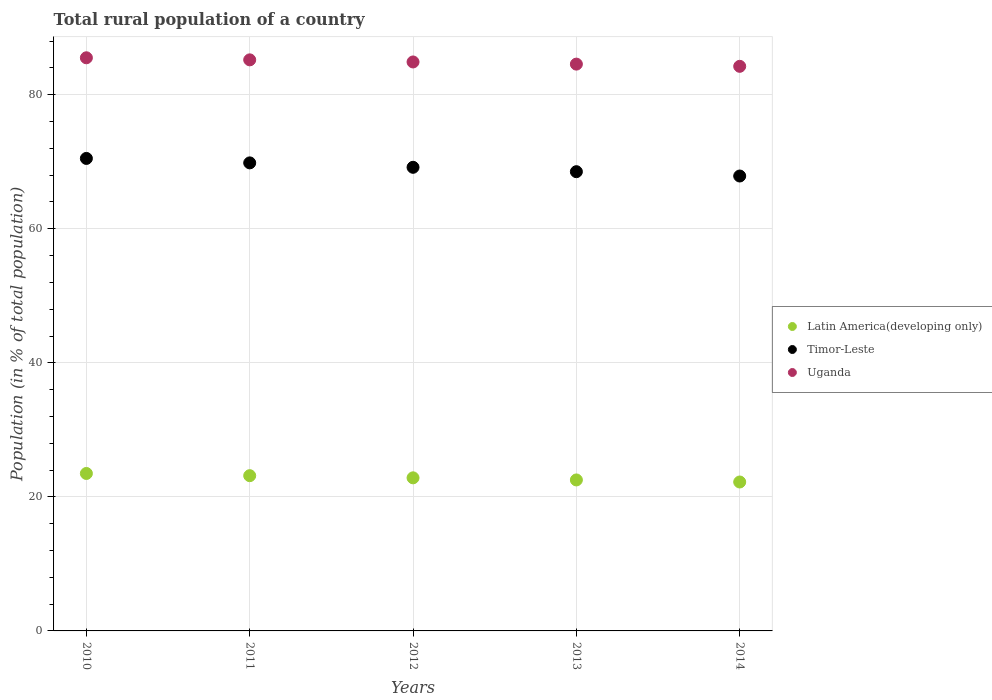What is the rural population in Latin America(developing only) in 2013?
Your response must be concise. 22.53. Across all years, what is the maximum rural population in Timor-Leste?
Provide a short and direct response. 70.49. Across all years, what is the minimum rural population in Timor-Leste?
Offer a very short reply. 67.87. In which year was the rural population in Latin America(developing only) minimum?
Your answer should be very brief. 2014. What is the total rural population in Uganda in the graph?
Your response must be concise. 424.39. What is the difference between the rural population in Timor-Leste in 2011 and that in 2013?
Ensure brevity in your answer.  1.31. What is the difference between the rural population in Uganda in 2013 and the rural population in Latin America(developing only) in 2010?
Offer a very short reply. 61.07. What is the average rural population in Timor-Leste per year?
Give a very brief answer. 69.17. In the year 2014, what is the difference between the rural population in Timor-Leste and rural population in Latin America(developing only)?
Provide a succinct answer. 45.65. In how many years, is the rural population in Timor-Leste greater than 60 %?
Make the answer very short. 5. What is the ratio of the rural population in Latin America(developing only) in 2010 to that in 2013?
Offer a terse response. 1.04. Is the rural population in Timor-Leste in 2012 less than that in 2013?
Offer a very short reply. No. Is the difference between the rural population in Timor-Leste in 2012 and 2013 greater than the difference between the rural population in Latin America(developing only) in 2012 and 2013?
Provide a short and direct response. Yes. What is the difference between the highest and the second highest rural population in Uganda?
Your answer should be compact. 0.31. What is the difference between the highest and the lowest rural population in Uganda?
Offer a terse response. 1.27. In how many years, is the rural population in Latin America(developing only) greater than the average rural population in Latin America(developing only) taken over all years?
Keep it short and to the point. 2. Does the rural population in Timor-Leste monotonically increase over the years?
Offer a terse response. No. Is the rural population in Latin America(developing only) strictly less than the rural population in Timor-Leste over the years?
Provide a succinct answer. Yes. How many years are there in the graph?
Offer a terse response. 5. What is the difference between two consecutive major ticks on the Y-axis?
Provide a succinct answer. 20. Are the values on the major ticks of Y-axis written in scientific E-notation?
Keep it short and to the point. No. Does the graph contain grids?
Offer a terse response. Yes. Where does the legend appear in the graph?
Provide a succinct answer. Center right. How are the legend labels stacked?
Provide a short and direct response. Vertical. What is the title of the graph?
Make the answer very short. Total rural population of a country. Does "Guinea" appear as one of the legend labels in the graph?
Give a very brief answer. No. What is the label or title of the X-axis?
Ensure brevity in your answer.  Years. What is the label or title of the Y-axis?
Your answer should be very brief. Population (in % of total population). What is the Population (in % of total population) of Latin America(developing only) in 2010?
Provide a short and direct response. 23.49. What is the Population (in % of total population) of Timor-Leste in 2010?
Your answer should be very brief. 70.49. What is the Population (in % of total population) of Uganda in 2010?
Make the answer very short. 85.51. What is the Population (in % of total population) in Latin America(developing only) in 2011?
Your response must be concise. 23.16. What is the Population (in % of total population) in Timor-Leste in 2011?
Give a very brief answer. 69.83. What is the Population (in % of total population) in Uganda in 2011?
Offer a terse response. 85.2. What is the Population (in % of total population) in Latin America(developing only) in 2012?
Give a very brief answer. 22.84. What is the Population (in % of total population) in Timor-Leste in 2012?
Provide a succinct answer. 69.17. What is the Population (in % of total population) in Uganda in 2012?
Keep it short and to the point. 84.89. What is the Population (in % of total population) in Latin America(developing only) in 2013?
Your answer should be compact. 22.53. What is the Population (in % of total population) of Timor-Leste in 2013?
Make the answer very short. 68.52. What is the Population (in % of total population) of Uganda in 2013?
Your answer should be compact. 84.56. What is the Population (in % of total population) in Latin America(developing only) in 2014?
Ensure brevity in your answer.  22.22. What is the Population (in % of total population) of Timor-Leste in 2014?
Your answer should be very brief. 67.87. What is the Population (in % of total population) in Uganda in 2014?
Your answer should be compact. 84.23. Across all years, what is the maximum Population (in % of total population) in Latin America(developing only)?
Give a very brief answer. 23.49. Across all years, what is the maximum Population (in % of total population) in Timor-Leste?
Your answer should be very brief. 70.49. Across all years, what is the maximum Population (in % of total population) of Uganda?
Ensure brevity in your answer.  85.51. Across all years, what is the minimum Population (in % of total population) in Latin America(developing only)?
Provide a short and direct response. 22.22. Across all years, what is the minimum Population (in % of total population) in Timor-Leste?
Your answer should be compact. 67.87. Across all years, what is the minimum Population (in % of total population) in Uganda?
Provide a succinct answer. 84.23. What is the total Population (in % of total population) of Latin America(developing only) in the graph?
Give a very brief answer. 114.24. What is the total Population (in % of total population) of Timor-Leste in the graph?
Provide a succinct answer. 345.87. What is the total Population (in % of total population) in Uganda in the graph?
Give a very brief answer. 424.39. What is the difference between the Population (in % of total population) in Latin America(developing only) in 2010 and that in 2011?
Your answer should be very brief. 0.33. What is the difference between the Population (in % of total population) in Timor-Leste in 2010 and that in 2011?
Give a very brief answer. 0.66. What is the difference between the Population (in % of total population) of Uganda in 2010 and that in 2011?
Give a very brief answer. 0.31. What is the difference between the Population (in % of total population) of Latin America(developing only) in 2010 and that in 2012?
Offer a very short reply. 0.65. What is the difference between the Population (in % of total population) in Timor-Leste in 2010 and that in 2012?
Ensure brevity in your answer.  1.32. What is the difference between the Population (in % of total population) of Uganda in 2010 and that in 2012?
Ensure brevity in your answer.  0.62. What is the difference between the Population (in % of total population) in Latin America(developing only) in 2010 and that in 2013?
Keep it short and to the point. 0.97. What is the difference between the Population (in % of total population) of Timor-Leste in 2010 and that in 2013?
Ensure brevity in your answer.  1.98. What is the difference between the Population (in % of total population) of Uganda in 2010 and that in 2013?
Offer a terse response. 0.94. What is the difference between the Population (in % of total population) of Latin America(developing only) in 2010 and that in 2014?
Your response must be concise. 1.27. What is the difference between the Population (in % of total population) of Timor-Leste in 2010 and that in 2014?
Ensure brevity in your answer.  2.62. What is the difference between the Population (in % of total population) of Uganda in 2010 and that in 2014?
Keep it short and to the point. 1.27. What is the difference between the Population (in % of total population) in Latin America(developing only) in 2011 and that in 2012?
Offer a very short reply. 0.32. What is the difference between the Population (in % of total population) of Timor-Leste in 2011 and that in 2012?
Provide a succinct answer. 0.66. What is the difference between the Population (in % of total population) of Uganda in 2011 and that in 2012?
Your answer should be very brief. 0.32. What is the difference between the Population (in % of total population) in Latin America(developing only) in 2011 and that in 2013?
Provide a short and direct response. 0.64. What is the difference between the Population (in % of total population) of Timor-Leste in 2011 and that in 2013?
Your response must be concise. 1.31. What is the difference between the Population (in % of total population) of Uganda in 2011 and that in 2013?
Your answer should be compact. 0.64. What is the difference between the Population (in % of total population) in Latin America(developing only) in 2011 and that in 2014?
Ensure brevity in your answer.  0.94. What is the difference between the Population (in % of total population) in Timor-Leste in 2011 and that in 2014?
Provide a succinct answer. 1.96. What is the difference between the Population (in % of total population) in Latin America(developing only) in 2012 and that in 2013?
Give a very brief answer. 0.31. What is the difference between the Population (in % of total population) of Timor-Leste in 2012 and that in 2013?
Make the answer very short. 0.65. What is the difference between the Population (in % of total population) in Uganda in 2012 and that in 2013?
Your response must be concise. 0.32. What is the difference between the Population (in % of total population) of Latin America(developing only) in 2012 and that in 2014?
Your response must be concise. 0.62. What is the difference between the Population (in % of total population) in Timor-Leste in 2012 and that in 2014?
Offer a terse response. 1.3. What is the difference between the Population (in % of total population) in Uganda in 2012 and that in 2014?
Give a very brief answer. 0.65. What is the difference between the Population (in % of total population) of Latin America(developing only) in 2013 and that in 2014?
Give a very brief answer. 0.31. What is the difference between the Population (in % of total population) in Timor-Leste in 2013 and that in 2014?
Keep it short and to the point. 0.65. What is the difference between the Population (in % of total population) in Uganda in 2013 and that in 2014?
Your answer should be very brief. 0.33. What is the difference between the Population (in % of total population) in Latin America(developing only) in 2010 and the Population (in % of total population) in Timor-Leste in 2011?
Your answer should be compact. -46.34. What is the difference between the Population (in % of total population) of Latin America(developing only) in 2010 and the Population (in % of total population) of Uganda in 2011?
Your answer should be very brief. -61.71. What is the difference between the Population (in % of total population) in Timor-Leste in 2010 and the Population (in % of total population) in Uganda in 2011?
Offer a very short reply. -14.71. What is the difference between the Population (in % of total population) in Latin America(developing only) in 2010 and the Population (in % of total population) in Timor-Leste in 2012?
Provide a succinct answer. -45.68. What is the difference between the Population (in % of total population) in Latin America(developing only) in 2010 and the Population (in % of total population) in Uganda in 2012?
Your answer should be compact. -61.39. What is the difference between the Population (in % of total population) of Timor-Leste in 2010 and the Population (in % of total population) of Uganda in 2012?
Your response must be concise. -14.39. What is the difference between the Population (in % of total population) of Latin America(developing only) in 2010 and the Population (in % of total population) of Timor-Leste in 2013?
Ensure brevity in your answer.  -45.02. What is the difference between the Population (in % of total population) in Latin America(developing only) in 2010 and the Population (in % of total population) in Uganda in 2013?
Offer a very short reply. -61.07. What is the difference between the Population (in % of total population) in Timor-Leste in 2010 and the Population (in % of total population) in Uganda in 2013?
Your response must be concise. -14.07. What is the difference between the Population (in % of total population) of Latin America(developing only) in 2010 and the Population (in % of total population) of Timor-Leste in 2014?
Your answer should be compact. -44.38. What is the difference between the Population (in % of total population) of Latin America(developing only) in 2010 and the Population (in % of total population) of Uganda in 2014?
Your answer should be very brief. -60.74. What is the difference between the Population (in % of total population) in Timor-Leste in 2010 and the Population (in % of total population) in Uganda in 2014?
Offer a very short reply. -13.74. What is the difference between the Population (in % of total population) of Latin America(developing only) in 2011 and the Population (in % of total population) of Timor-Leste in 2012?
Make the answer very short. -46.01. What is the difference between the Population (in % of total population) in Latin America(developing only) in 2011 and the Population (in % of total population) in Uganda in 2012?
Offer a very short reply. -61.72. What is the difference between the Population (in % of total population) in Timor-Leste in 2011 and the Population (in % of total population) in Uganda in 2012?
Give a very brief answer. -15.06. What is the difference between the Population (in % of total population) of Latin America(developing only) in 2011 and the Population (in % of total population) of Timor-Leste in 2013?
Offer a terse response. -45.35. What is the difference between the Population (in % of total population) of Latin America(developing only) in 2011 and the Population (in % of total population) of Uganda in 2013?
Keep it short and to the point. -61.4. What is the difference between the Population (in % of total population) in Timor-Leste in 2011 and the Population (in % of total population) in Uganda in 2013?
Provide a succinct answer. -14.73. What is the difference between the Population (in % of total population) of Latin America(developing only) in 2011 and the Population (in % of total population) of Timor-Leste in 2014?
Your response must be concise. -44.71. What is the difference between the Population (in % of total population) of Latin America(developing only) in 2011 and the Population (in % of total population) of Uganda in 2014?
Offer a terse response. -61.07. What is the difference between the Population (in % of total population) in Timor-Leste in 2011 and the Population (in % of total population) in Uganda in 2014?
Your answer should be compact. -14.4. What is the difference between the Population (in % of total population) in Latin America(developing only) in 2012 and the Population (in % of total population) in Timor-Leste in 2013?
Offer a terse response. -45.68. What is the difference between the Population (in % of total population) of Latin America(developing only) in 2012 and the Population (in % of total population) of Uganda in 2013?
Keep it short and to the point. -61.72. What is the difference between the Population (in % of total population) of Timor-Leste in 2012 and the Population (in % of total population) of Uganda in 2013?
Ensure brevity in your answer.  -15.39. What is the difference between the Population (in % of total population) of Latin America(developing only) in 2012 and the Population (in % of total population) of Timor-Leste in 2014?
Your answer should be compact. -45.03. What is the difference between the Population (in % of total population) of Latin America(developing only) in 2012 and the Population (in % of total population) of Uganda in 2014?
Ensure brevity in your answer.  -61.39. What is the difference between the Population (in % of total population) in Timor-Leste in 2012 and the Population (in % of total population) in Uganda in 2014?
Ensure brevity in your answer.  -15.07. What is the difference between the Population (in % of total population) in Latin America(developing only) in 2013 and the Population (in % of total population) in Timor-Leste in 2014?
Keep it short and to the point. -45.34. What is the difference between the Population (in % of total population) in Latin America(developing only) in 2013 and the Population (in % of total population) in Uganda in 2014?
Ensure brevity in your answer.  -61.71. What is the difference between the Population (in % of total population) in Timor-Leste in 2013 and the Population (in % of total population) in Uganda in 2014?
Your answer should be compact. -15.72. What is the average Population (in % of total population) in Latin America(developing only) per year?
Keep it short and to the point. 22.85. What is the average Population (in % of total population) of Timor-Leste per year?
Offer a very short reply. 69.17. What is the average Population (in % of total population) of Uganda per year?
Your response must be concise. 84.88. In the year 2010, what is the difference between the Population (in % of total population) of Latin America(developing only) and Population (in % of total population) of Timor-Leste?
Offer a terse response. -47. In the year 2010, what is the difference between the Population (in % of total population) of Latin America(developing only) and Population (in % of total population) of Uganda?
Keep it short and to the point. -62.02. In the year 2010, what is the difference between the Population (in % of total population) of Timor-Leste and Population (in % of total population) of Uganda?
Provide a succinct answer. -15.02. In the year 2011, what is the difference between the Population (in % of total population) in Latin America(developing only) and Population (in % of total population) in Timor-Leste?
Keep it short and to the point. -46.67. In the year 2011, what is the difference between the Population (in % of total population) in Latin America(developing only) and Population (in % of total population) in Uganda?
Give a very brief answer. -62.04. In the year 2011, what is the difference between the Population (in % of total population) in Timor-Leste and Population (in % of total population) in Uganda?
Ensure brevity in your answer.  -15.37. In the year 2012, what is the difference between the Population (in % of total population) of Latin America(developing only) and Population (in % of total population) of Timor-Leste?
Your answer should be very brief. -46.33. In the year 2012, what is the difference between the Population (in % of total population) of Latin America(developing only) and Population (in % of total population) of Uganda?
Provide a succinct answer. -62.05. In the year 2012, what is the difference between the Population (in % of total population) in Timor-Leste and Population (in % of total population) in Uganda?
Offer a terse response. -15.72. In the year 2013, what is the difference between the Population (in % of total population) of Latin America(developing only) and Population (in % of total population) of Timor-Leste?
Ensure brevity in your answer.  -45.99. In the year 2013, what is the difference between the Population (in % of total population) of Latin America(developing only) and Population (in % of total population) of Uganda?
Make the answer very short. -62.04. In the year 2013, what is the difference between the Population (in % of total population) in Timor-Leste and Population (in % of total population) in Uganda?
Keep it short and to the point. -16.05. In the year 2014, what is the difference between the Population (in % of total population) in Latin America(developing only) and Population (in % of total population) in Timor-Leste?
Your answer should be very brief. -45.65. In the year 2014, what is the difference between the Population (in % of total population) of Latin America(developing only) and Population (in % of total population) of Uganda?
Your answer should be compact. -62.02. In the year 2014, what is the difference between the Population (in % of total population) of Timor-Leste and Population (in % of total population) of Uganda?
Offer a very short reply. -16.36. What is the ratio of the Population (in % of total population) of Latin America(developing only) in 2010 to that in 2011?
Your answer should be compact. 1.01. What is the ratio of the Population (in % of total population) of Timor-Leste in 2010 to that in 2011?
Offer a very short reply. 1.01. What is the ratio of the Population (in % of total population) of Uganda in 2010 to that in 2011?
Offer a terse response. 1. What is the ratio of the Population (in % of total population) of Latin America(developing only) in 2010 to that in 2012?
Ensure brevity in your answer.  1.03. What is the ratio of the Population (in % of total population) of Timor-Leste in 2010 to that in 2012?
Provide a short and direct response. 1.02. What is the ratio of the Population (in % of total population) of Uganda in 2010 to that in 2012?
Make the answer very short. 1.01. What is the ratio of the Population (in % of total population) in Latin America(developing only) in 2010 to that in 2013?
Your answer should be compact. 1.04. What is the ratio of the Population (in % of total population) in Timor-Leste in 2010 to that in 2013?
Give a very brief answer. 1.03. What is the ratio of the Population (in % of total population) of Uganda in 2010 to that in 2013?
Your answer should be very brief. 1.01. What is the ratio of the Population (in % of total population) of Latin America(developing only) in 2010 to that in 2014?
Make the answer very short. 1.06. What is the ratio of the Population (in % of total population) of Timor-Leste in 2010 to that in 2014?
Your response must be concise. 1.04. What is the ratio of the Population (in % of total population) of Uganda in 2010 to that in 2014?
Provide a short and direct response. 1.02. What is the ratio of the Population (in % of total population) of Latin America(developing only) in 2011 to that in 2012?
Give a very brief answer. 1.01. What is the ratio of the Population (in % of total population) of Timor-Leste in 2011 to that in 2012?
Offer a terse response. 1.01. What is the ratio of the Population (in % of total population) in Uganda in 2011 to that in 2012?
Keep it short and to the point. 1. What is the ratio of the Population (in % of total population) in Latin America(developing only) in 2011 to that in 2013?
Keep it short and to the point. 1.03. What is the ratio of the Population (in % of total population) of Timor-Leste in 2011 to that in 2013?
Ensure brevity in your answer.  1.02. What is the ratio of the Population (in % of total population) in Uganda in 2011 to that in 2013?
Your response must be concise. 1.01. What is the ratio of the Population (in % of total population) in Latin America(developing only) in 2011 to that in 2014?
Provide a short and direct response. 1.04. What is the ratio of the Population (in % of total population) of Timor-Leste in 2011 to that in 2014?
Keep it short and to the point. 1.03. What is the ratio of the Population (in % of total population) of Uganda in 2011 to that in 2014?
Give a very brief answer. 1.01. What is the ratio of the Population (in % of total population) in Latin America(developing only) in 2012 to that in 2013?
Ensure brevity in your answer.  1.01. What is the ratio of the Population (in % of total population) of Timor-Leste in 2012 to that in 2013?
Offer a terse response. 1.01. What is the ratio of the Population (in % of total population) of Latin America(developing only) in 2012 to that in 2014?
Make the answer very short. 1.03. What is the ratio of the Population (in % of total population) in Timor-Leste in 2012 to that in 2014?
Give a very brief answer. 1.02. What is the ratio of the Population (in % of total population) in Uganda in 2012 to that in 2014?
Give a very brief answer. 1.01. What is the ratio of the Population (in % of total population) in Latin America(developing only) in 2013 to that in 2014?
Offer a terse response. 1.01. What is the ratio of the Population (in % of total population) of Timor-Leste in 2013 to that in 2014?
Your answer should be very brief. 1.01. What is the ratio of the Population (in % of total population) of Uganda in 2013 to that in 2014?
Provide a short and direct response. 1. What is the difference between the highest and the second highest Population (in % of total population) of Latin America(developing only)?
Your answer should be compact. 0.33. What is the difference between the highest and the second highest Population (in % of total population) of Timor-Leste?
Offer a very short reply. 0.66. What is the difference between the highest and the second highest Population (in % of total population) of Uganda?
Ensure brevity in your answer.  0.31. What is the difference between the highest and the lowest Population (in % of total population) of Latin America(developing only)?
Offer a terse response. 1.27. What is the difference between the highest and the lowest Population (in % of total population) of Timor-Leste?
Make the answer very short. 2.62. What is the difference between the highest and the lowest Population (in % of total population) of Uganda?
Make the answer very short. 1.27. 